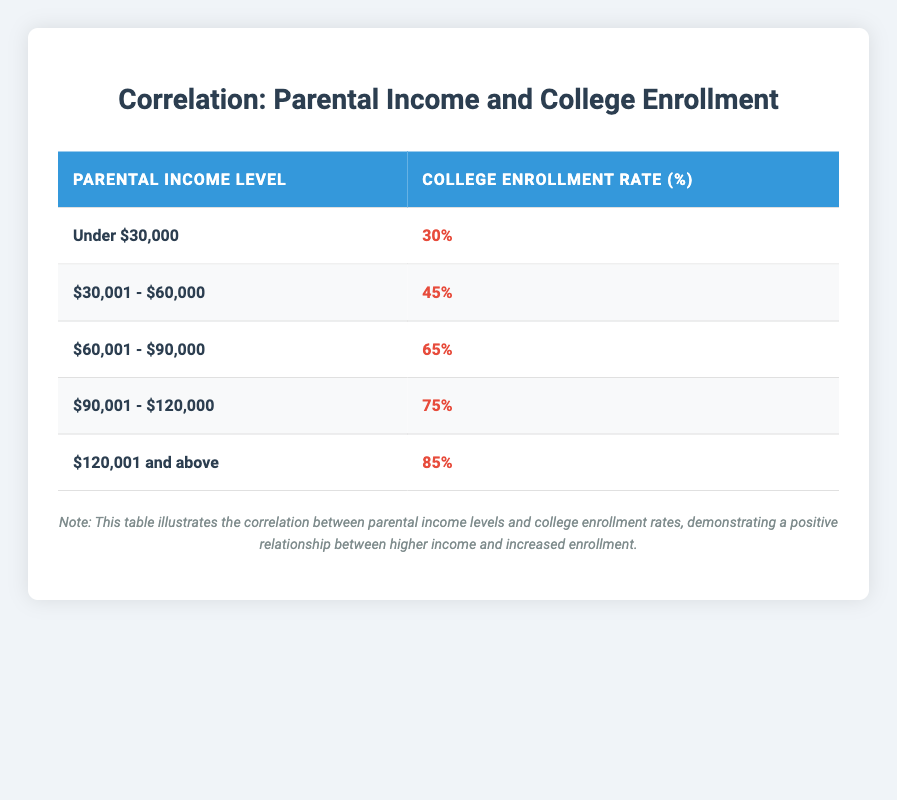What is the college enrollment rate for households with a parental income level of $60,001 - $90,000? The table indicates that for the income level of $60,001 - $90,000, the college enrollment rate is directly stated as 65%.
Answer: 65% What is the difference in college enrollment rates between the lowest and the highest parental income levels? For the lowest income level (Under $30,000), the enrollment rate is 30%. For the highest income level ($120,001 and above), it is 85%. The difference is calculated as 85 - 30 = 55.
Answer: 55% Is the college enrollment rate for income level $30,001 - $60,000 higher than 40%? The enrollment rate for this income bracket is listed as 45%. Since 45% is indeed higher than 40%, the statement is true.
Answer: Yes What is the average college enrollment rate of parents earning under $90,000? The income levels under $90,000 are "Under $30,000" (30%), "$30,001 - $60,000" (45%), and "$60,001 - $90,000" (65%). To find the average, we sum 30 + 45 + 65 = 140, and then divide by the number of income levels (3), resulting in an average of 140 / 3 = 46.67%.
Answer: 46.67% For which parental income level does the enrollment rate rise above 50%? By examining the table, the income level "$60,001 - $90,000" has a rate of 65%, which is above 50%. Therefore, all levels from "$60,001 - $90,000" up to "$120,001 and above" qualify, since they also exceed this threshold.
Answer: $60,001 - $90,000, $90,001 - $120,000, $120,001 and above 